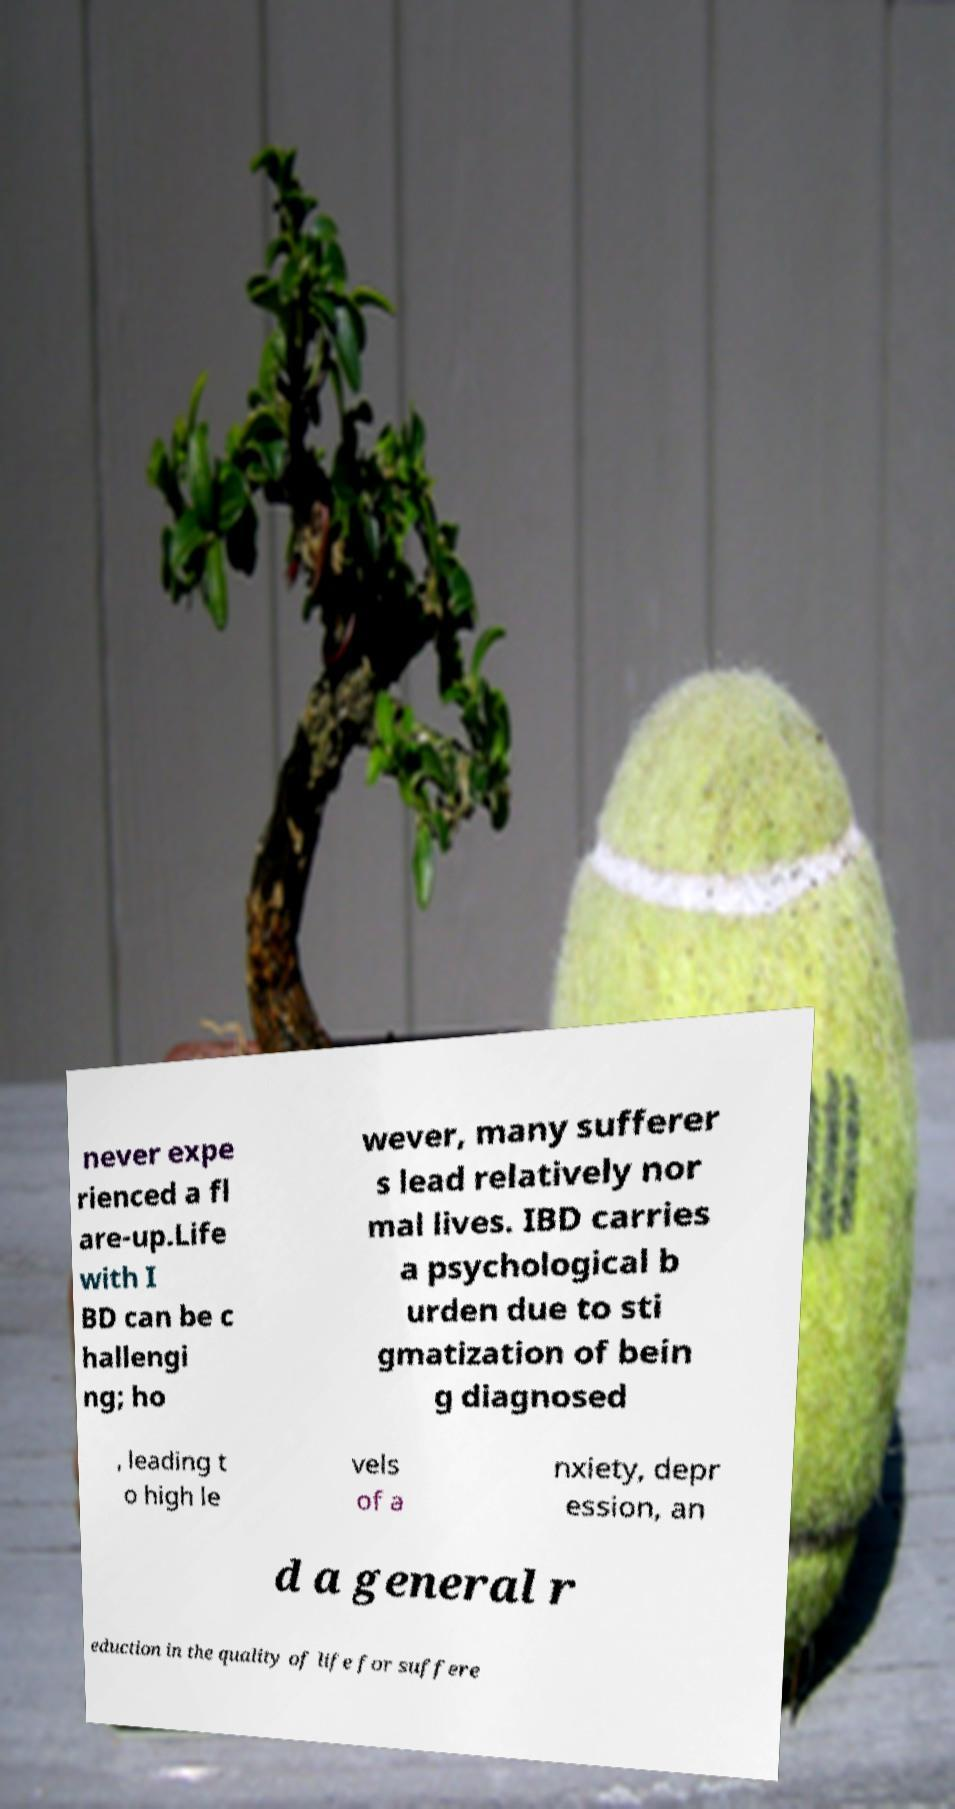Could you assist in decoding the text presented in this image and type it out clearly? never expe rienced a fl are-up.Life with I BD can be c hallengi ng; ho wever, many sufferer s lead relatively nor mal lives. IBD carries a psychological b urden due to sti gmatization of bein g diagnosed , leading t o high le vels of a nxiety, depr ession, an d a general r eduction in the quality of life for suffere 